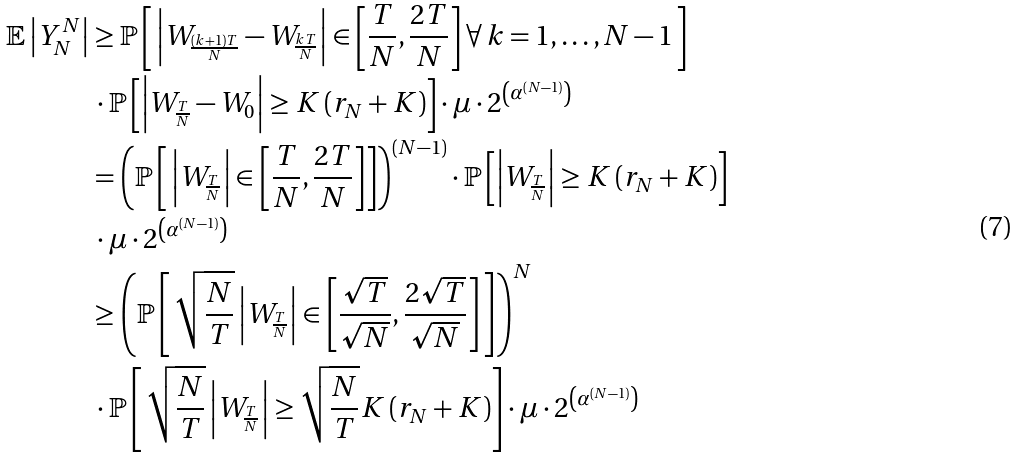<formula> <loc_0><loc_0><loc_500><loc_500>\mathbb { E } \left | Y ^ { N } _ { N } \right | & \geq \mathbb { P } \left [ \, \left | W _ { \frac { ( k + 1 ) T } { N } } - W _ { \frac { k T } { N } } \right | \in \left [ \frac { T } { N } , \frac { 2 T } { N } \right ] \forall \, k = 1 , \dots , N - 1 \, \right ] \\ & \, \cdot \mathbb { P } \left [ \left | W _ { \frac { T } { N } } - W _ { 0 } \right | \geq K \left ( r _ { N } + K \right ) \right ] \cdot \mu \cdot 2 ^ { \left ( \alpha ^ { \left ( N - 1 \right ) } \right ) } \\ & = \left ( \mathbb { P } \left [ \, \left | W _ { \frac { T } { N } } \right | \in \left [ \frac { T } { N } , \frac { 2 T } { N } \right ] \right ] \right ) ^ { \left ( N - 1 \right ) } \cdot \mathbb { P } \left [ \left | W _ { \frac { T } { N } } \right | \geq K \left ( r _ { N } + K \right ) \right ] \\ & \, \cdot \mu \cdot 2 ^ { \left ( \alpha ^ { \left ( N - 1 \right ) } \right ) } \\ & \geq \left ( \mathbb { P } \left [ \, \sqrt { \frac { N } { T } } \left | W _ { \frac { T } { N } } \right | \in \left [ \frac { \sqrt { T } } { \sqrt { N } } , \frac { 2 \sqrt { T } } { \sqrt { N } } \right ] \, \right ] \right ) ^ { N } \\ & \, \cdot \mathbb { P } \left [ \, \sqrt { \frac { N } { T } } \left | W _ { \frac { T } { N } } \right | \geq \sqrt { \frac { N } { T } } K \left ( r _ { N } + K \right ) \right ] \cdot \mu \cdot 2 ^ { \left ( \alpha ^ { \left ( N - 1 \right ) } \right ) }</formula> 